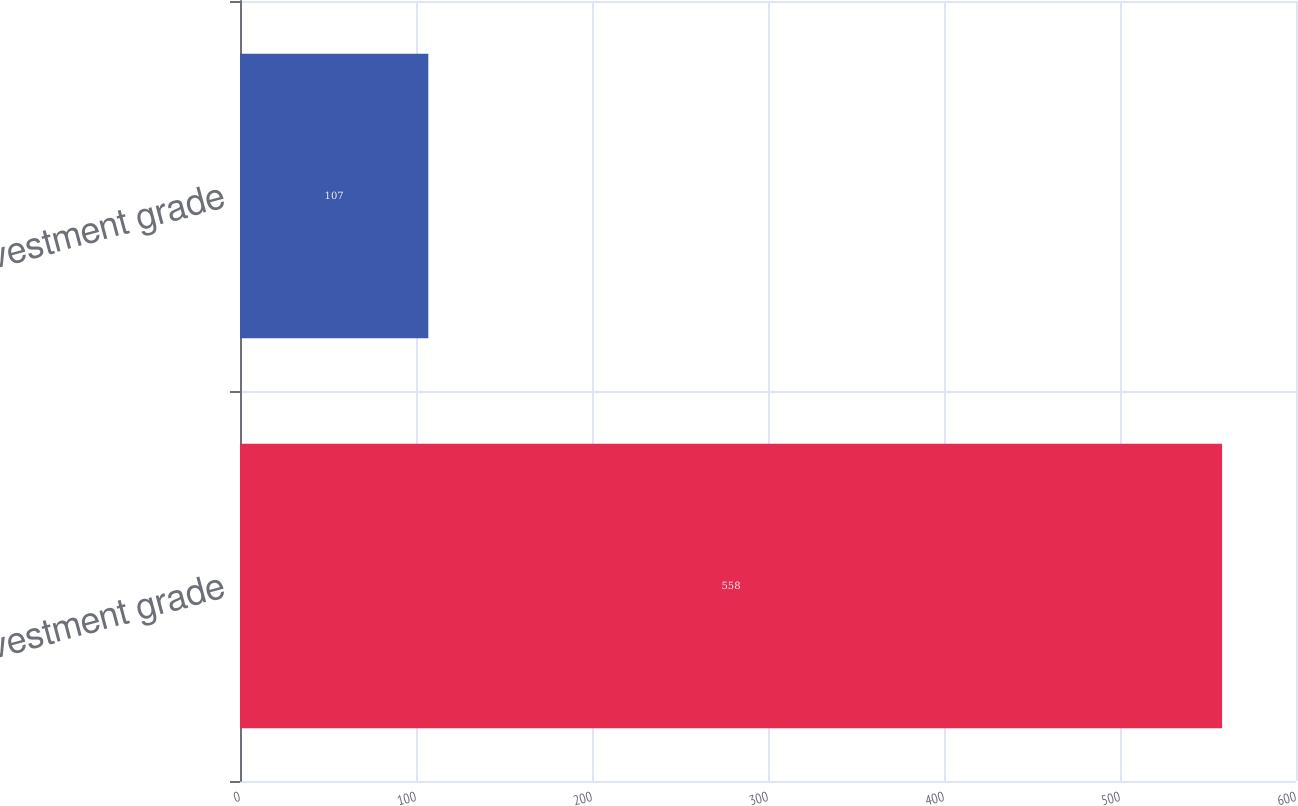<chart> <loc_0><loc_0><loc_500><loc_500><bar_chart><fcel>Investment grade<fcel>Non-investment grade<nl><fcel>558<fcel>107<nl></chart> 